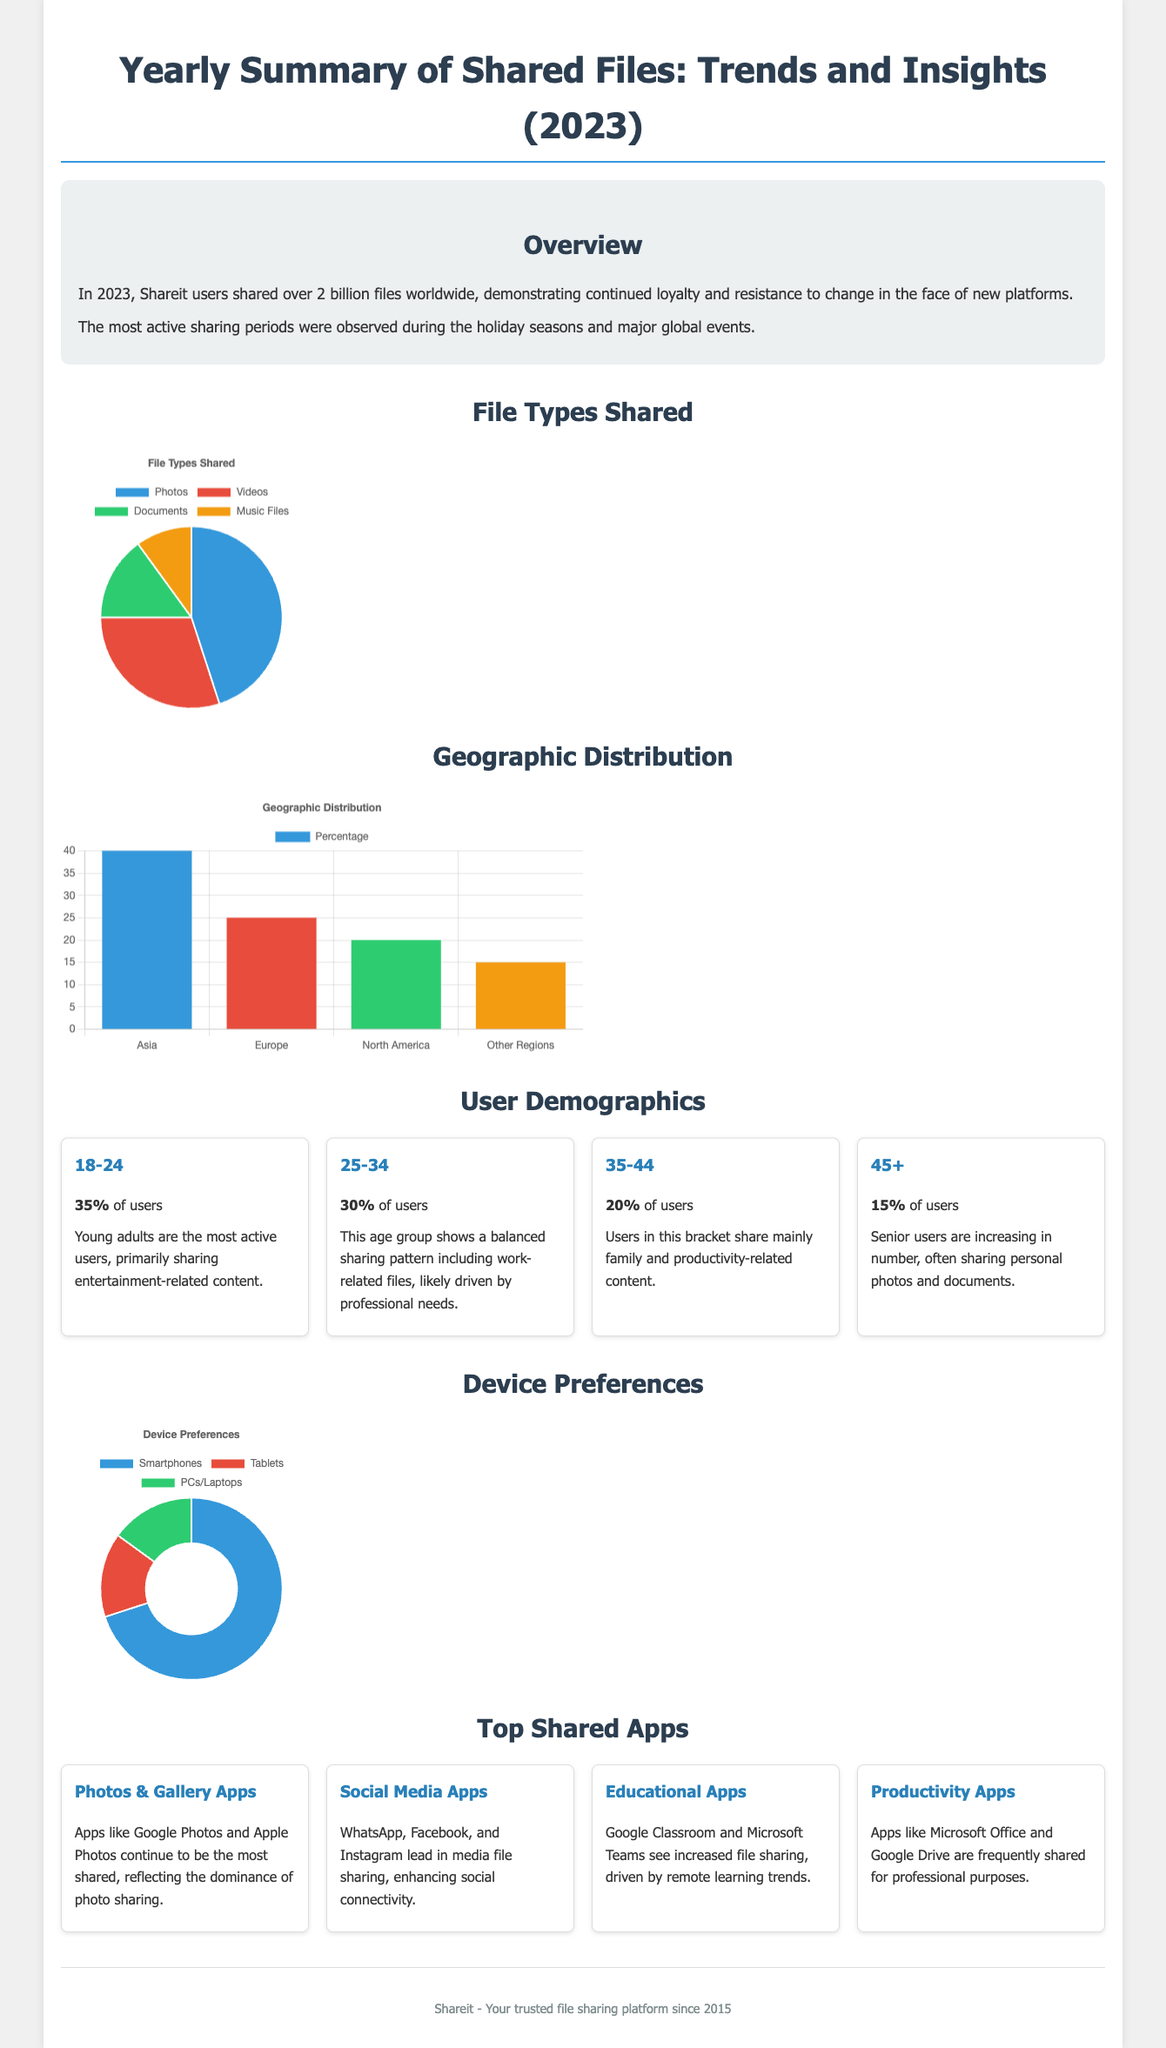What was the total number of files shared in 2023? The total number of files shared worldwide by Shareit users in 2023 is reported in the overview as over 2 billion files.
Answer: over 2 billion files What percentage of users are aged 18-24? The demographic section indicates that 35% of users fall into the 18-24 age category.
Answer: 35% What type of content do young adults primarily share? The document states that young adults primarily share entertainment-related content.
Answer: entertainment-related content Which continent has the highest percentage of users? The geographic distribution chart shows that Asia has the highest percentage, at 40%.
Answer: Asia What are the top two shared app categories? The document provides information on shared apps, with Photos & Gallery Apps and Social Media Apps being the top categories.
Answer: Photos & Gallery Apps, Social Media Apps How many demographics are listed in the user demographics section? The user demographics section contains four different age groups listed in the document.
Answer: four What is the percentage of users aged 45 and older? The user demographics section indicates that 15% of users belong to the 45+ age group.
Answer: 15% What device is preferred for file sharing according to user preferences? The device preferences chart shows that smartphones are preferred, with 70% of users opting for them.
Answer: smartphones What was the most active sharing period? The overview specifies that the most active sharing periods were during holiday seasons and major global events.
Answer: holiday seasons and major global events 